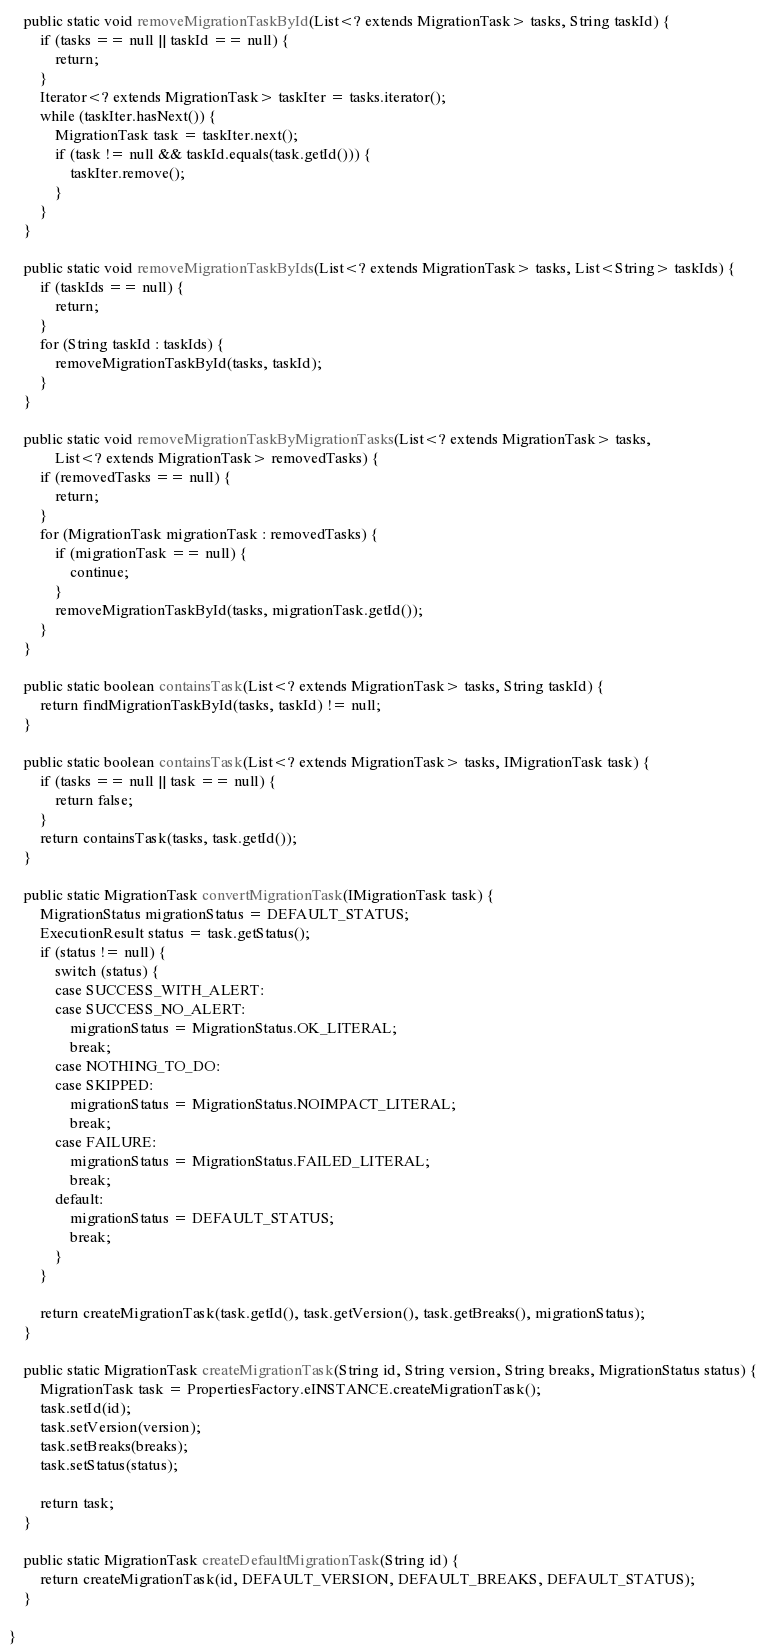<code> <loc_0><loc_0><loc_500><loc_500><_Java_>    public static void removeMigrationTaskById(List<? extends MigrationTask> tasks, String taskId) {
        if (tasks == null || taskId == null) {
            return;
        }
        Iterator<? extends MigrationTask> taskIter = tasks.iterator();
        while (taskIter.hasNext()) {
            MigrationTask task = taskIter.next();
            if (task != null && taskId.equals(task.getId())) {
                taskIter.remove();
            }
        }
    }

    public static void removeMigrationTaskByIds(List<? extends MigrationTask> tasks, List<String> taskIds) {
        if (taskIds == null) {
            return;
        }
        for (String taskId : taskIds) {
            removeMigrationTaskById(tasks, taskId);
        }
    }

    public static void removeMigrationTaskByMigrationTasks(List<? extends MigrationTask> tasks,
            List<? extends MigrationTask> removedTasks) {
        if (removedTasks == null) {
            return;
        }
        for (MigrationTask migrationTask : removedTasks) {
            if (migrationTask == null) {
                continue;
            }
            removeMigrationTaskById(tasks, migrationTask.getId());
        }
    }

    public static boolean containsTask(List<? extends MigrationTask> tasks, String taskId) {
        return findMigrationTaskById(tasks, taskId) != null;
    }

    public static boolean containsTask(List<? extends MigrationTask> tasks, IMigrationTask task) {
        if (tasks == null || task == null) {
            return false;
        }
        return containsTask(tasks, task.getId());
    }

    public static MigrationTask convertMigrationTask(IMigrationTask task) {
        MigrationStatus migrationStatus = DEFAULT_STATUS;
        ExecutionResult status = task.getStatus();
        if (status != null) {
            switch (status) {
            case SUCCESS_WITH_ALERT:
            case SUCCESS_NO_ALERT:
                migrationStatus = MigrationStatus.OK_LITERAL;
                break;
            case NOTHING_TO_DO:
            case SKIPPED:
                migrationStatus = MigrationStatus.NOIMPACT_LITERAL;
                break;
            case FAILURE:
                migrationStatus = MigrationStatus.FAILED_LITERAL;
                break;
            default:
                migrationStatus = DEFAULT_STATUS;
                break;
            }
        }

        return createMigrationTask(task.getId(), task.getVersion(), task.getBreaks(), migrationStatus);
    }

    public static MigrationTask createMigrationTask(String id, String version, String breaks, MigrationStatus status) {
        MigrationTask task = PropertiesFactory.eINSTANCE.createMigrationTask();
        task.setId(id);
        task.setVersion(version);
        task.setBreaks(breaks);
        task.setStatus(status);

        return task;
    }

    public static MigrationTask createDefaultMigrationTask(String id) {
        return createMigrationTask(id, DEFAULT_VERSION, DEFAULT_BREAKS, DEFAULT_STATUS);
    }

}
</code> 